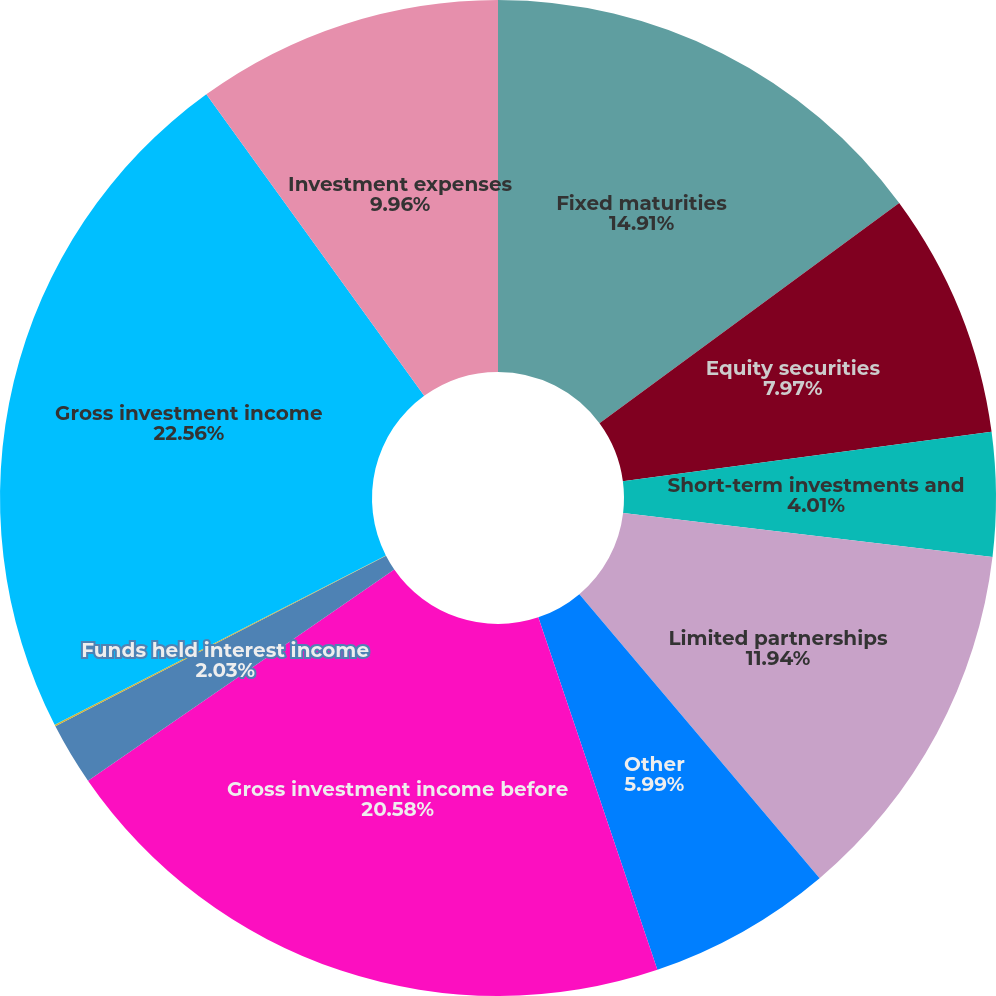Convert chart. <chart><loc_0><loc_0><loc_500><loc_500><pie_chart><fcel>Fixed maturities<fcel>Equity securities<fcel>Short-term investments and<fcel>Limited partnerships<fcel>Other<fcel>Gross investment income before<fcel>Funds held interest income<fcel>Future policy benefit reserve<fcel>Gross investment income<fcel>Investment expenses<nl><fcel>14.91%<fcel>7.97%<fcel>4.01%<fcel>11.94%<fcel>5.99%<fcel>20.58%<fcel>2.03%<fcel>0.05%<fcel>22.57%<fcel>9.96%<nl></chart> 